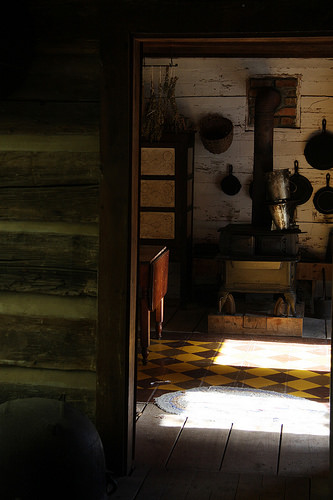<image>
Is the wall next to the stove? No. The wall is not positioned next to the stove. They are located in different areas of the scene. 